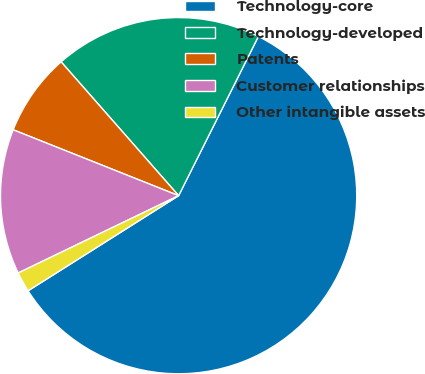Convert chart. <chart><loc_0><loc_0><loc_500><loc_500><pie_chart><fcel>Technology-core<fcel>Technology-developed<fcel>Patents<fcel>Customer relationships<fcel>Other intangible assets<nl><fcel>58.64%<fcel>18.86%<fcel>7.5%<fcel>13.18%<fcel>1.82%<nl></chart> 